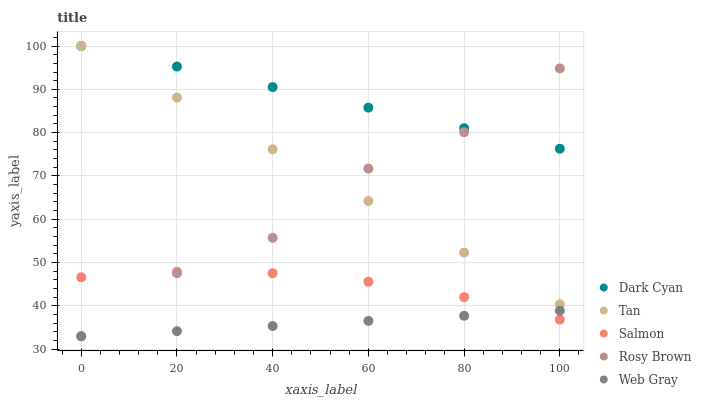Does Web Gray have the minimum area under the curve?
Answer yes or no. Yes. Does Dark Cyan have the maximum area under the curve?
Answer yes or no. Yes. Does Tan have the minimum area under the curve?
Answer yes or no. No. Does Tan have the maximum area under the curve?
Answer yes or no. No. Is Dark Cyan the smoothest?
Answer yes or no. Yes. Is Rosy Brown the roughest?
Answer yes or no. Yes. Is Rosy Brown the smoothest?
Answer yes or no. No. Is Tan the roughest?
Answer yes or no. No. Does Rosy Brown have the lowest value?
Answer yes or no. Yes. Does Tan have the lowest value?
Answer yes or no. No. Does Tan have the highest value?
Answer yes or no. Yes. Does Rosy Brown have the highest value?
Answer yes or no. No. Is Salmon less than Tan?
Answer yes or no. Yes. Is Tan greater than Web Gray?
Answer yes or no. Yes. Does Rosy Brown intersect Tan?
Answer yes or no. Yes. Is Rosy Brown less than Tan?
Answer yes or no. No. Is Rosy Brown greater than Tan?
Answer yes or no. No. Does Salmon intersect Tan?
Answer yes or no. No. 